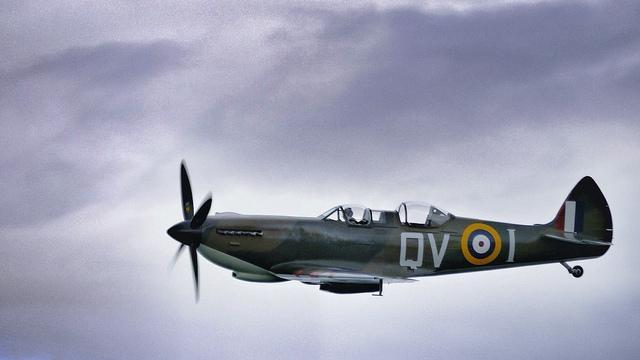Is the plane grounded?
Keep it brief. No. Is there 1 or 2 person in this plane?
Quick response, please. 1. Are the circles on the side a target?
Keep it brief. Yes. 